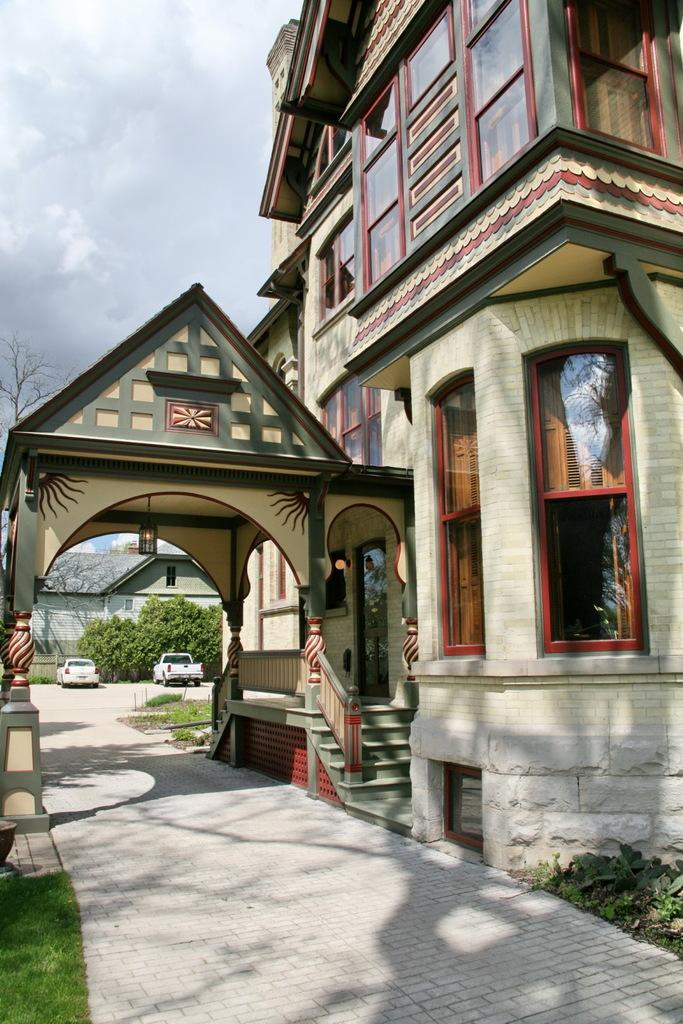What type of structures can be seen in the image? There are buildings in the image. What architectural feature is present in the image? There are stairs in the image. What can be seen in the background of the image? There are cars, trees, and the sky visible in the background of the image. What type of vegetation is present at the bottom of the image? There is grass at the bottom of the image. Where is the scarecrow standing in the image? There is no scarecrow present in the image. What type of sport is being played in the image? There is no sport or volleyball visible in the image. Is there a rifle visible in the image? There is no rifle present in the image. 